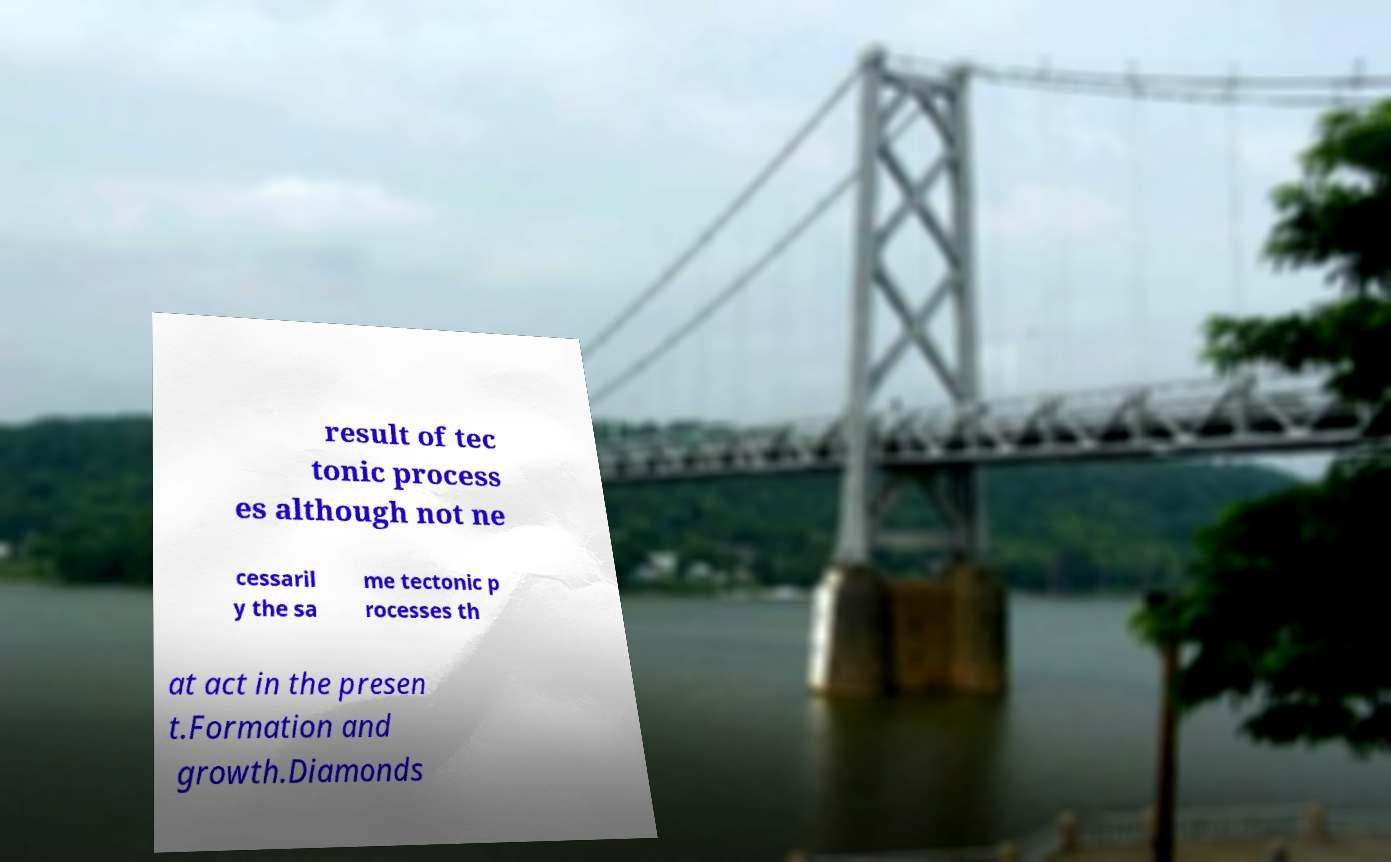Please identify and transcribe the text found in this image. result of tec tonic process es although not ne cessaril y the sa me tectonic p rocesses th at act in the presen t.Formation and growth.Diamonds 